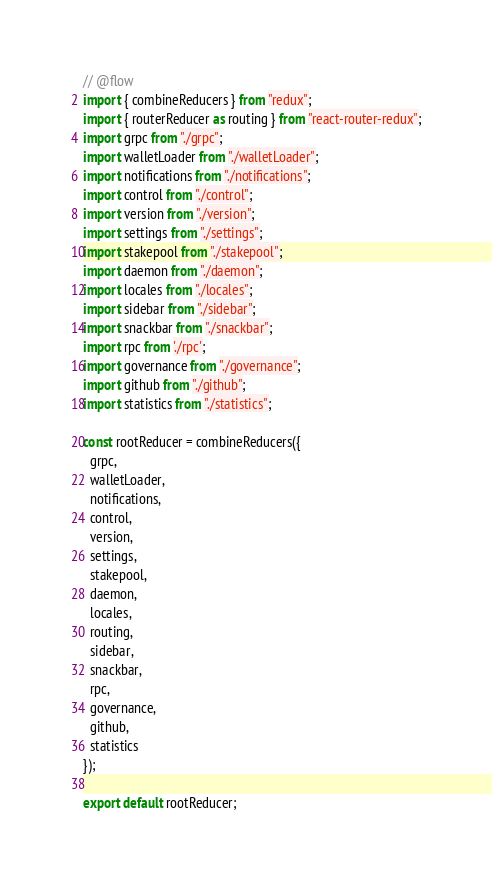<code> <loc_0><loc_0><loc_500><loc_500><_JavaScript_>// @flow
import { combineReducers } from "redux";
import { routerReducer as routing } from "react-router-redux";
import grpc from "./grpc";
import walletLoader from "./walletLoader";
import notifications from "./notifications";
import control from "./control";
import version from "./version";
import settings from "./settings";
import stakepool from "./stakepool";
import daemon from "./daemon";
import locales from "./locales";
import sidebar from "./sidebar";
import snackbar from "./snackbar";
import rpc from './rpc';
import governance from "./governance";
import github from "./github";
import statistics from "./statistics";

const rootReducer = combineReducers({
  grpc,
  walletLoader,
  notifications,
  control,
  version,
  settings,
  stakepool,
  daemon,
  locales,
  routing,
  sidebar,
  snackbar,
  rpc,
  governance,
  github,
  statistics
});

export default rootReducer;
</code> 